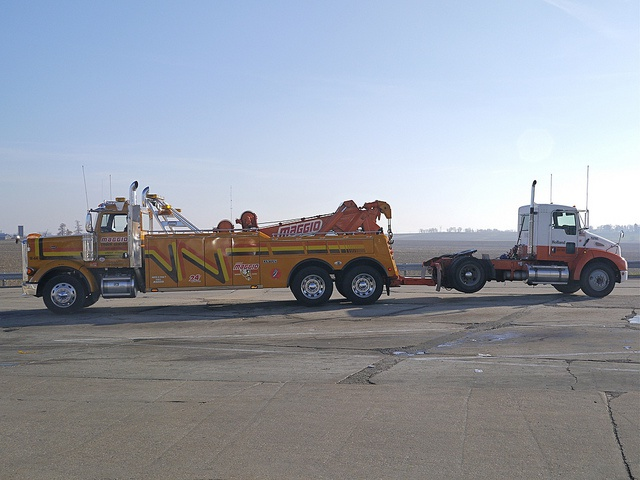Describe the objects in this image and their specific colors. I can see a truck in darkgray, black, maroon, and gray tones in this image. 